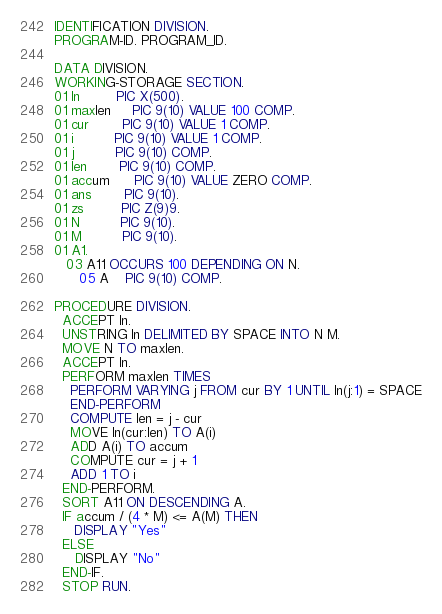Convert code to text. <code><loc_0><loc_0><loc_500><loc_500><_COBOL_>IDENTIFICATION DIVISION.
PROGRAM-ID. PROGRAM_ID.

DATA DIVISION.
WORKING-STORAGE SECTION.
01 ln         PIC X(500).
01 maxlen     PIC 9(10) VALUE 100 COMP.
01 cur        PIC 9(10) VALUE 1 COMP.
01 i          PIC 9(10) VALUE 1 COMP.
01 j          PIC 9(10) COMP.
01 len        PIC 9(10) COMP.
01 accum      PIC 9(10) VALUE ZERO COMP.
01 ans        PIC 9(10).
01 zs         PIC Z(9)9.
01 N          PIC 9(10).
01 M          PIC 9(10).
01 A1.
   03 A11 OCCURS 100 DEPENDING ON N.
      05 A    PIC 9(10) COMP.

PROCEDURE DIVISION.
  ACCEPT ln.
  UNSTRING ln DELIMITED BY SPACE INTO N M.
  MOVE N TO maxlen.
  ACCEPT ln.
  PERFORM maxlen TIMES
    PERFORM VARYING j FROM cur BY 1 UNTIL ln(j:1) = SPACE
    END-PERFORM
    COMPUTE len = j - cur
    MOVE ln(cur:len) TO A(i)
    ADD A(i) TO accum
    COMPUTE cur = j + 1
    ADD 1 TO i
  END-PERFORM.
  SORT A11 ON DESCENDING A.
  IF accum / (4 * M) <= A(M) THEN
     DISPLAY "Yes"
  ELSE
     DISPLAY "No"
  END-IF.
  STOP RUN.
</code> 